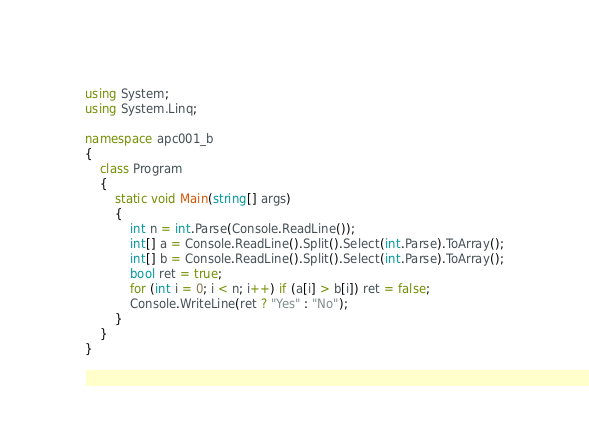<code> <loc_0><loc_0><loc_500><loc_500><_C#_>using System;
using System.Linq;

namespace apc001_b
{
    class Program
    {
        static void Main(string[] args)
        {
            int n = int.Parse(Console.ReadLine());
            int[] a = Console.ReadLine().Split().Select(int.Parse).ToArray();
            int[] b = Console.ReadLine().Split().Select(int.Parse).ToArray();
            bool ret = true;
            for (int i = 0; i < n; i++) if (a[i] > b[i]) ret = false;
            Console.WriteLine(ret ? "Yes" : "No");
        }
    }
}</code> 